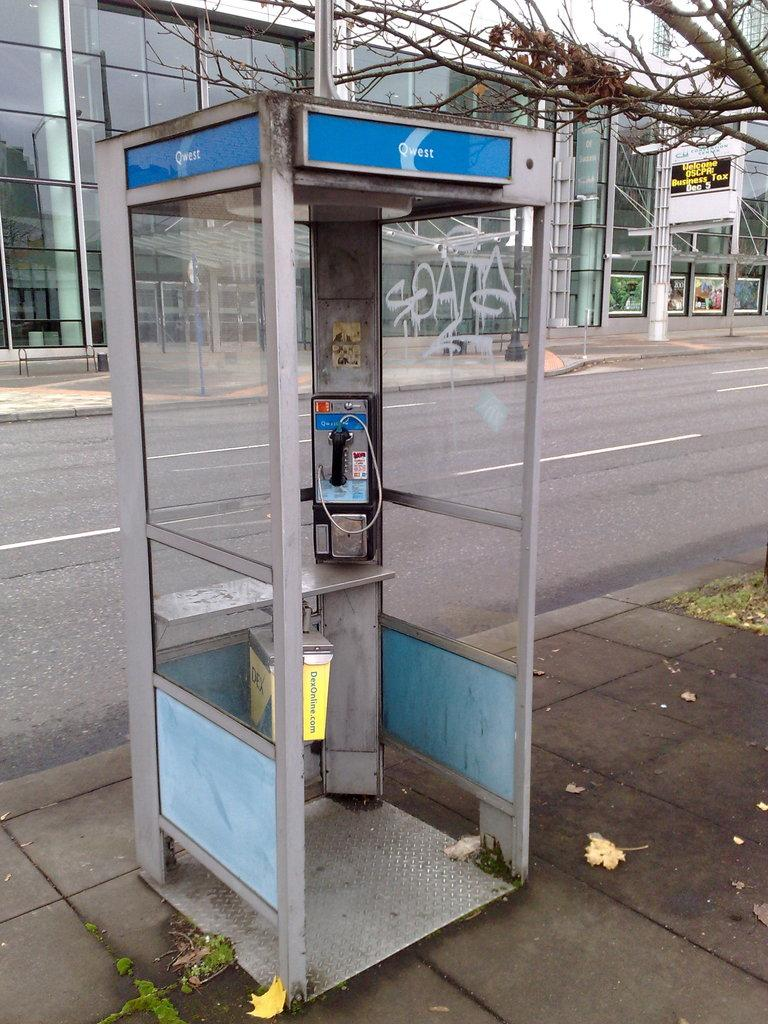What is the main structure in the middle of the image? There is a telephone booth in the middle of the image. What can be seen behind the telephone booth? There is a road and a tree behind the telephone booth. What other structure is visible behind the telephone booth? There is a building behind the telephone booth. What type of zinc is used to construct the telephone booth in the image? There is no information about the materials used to construct the telephone booth in the image. Is there a bomb visible in the image? No, there is no bomb present in the image. 